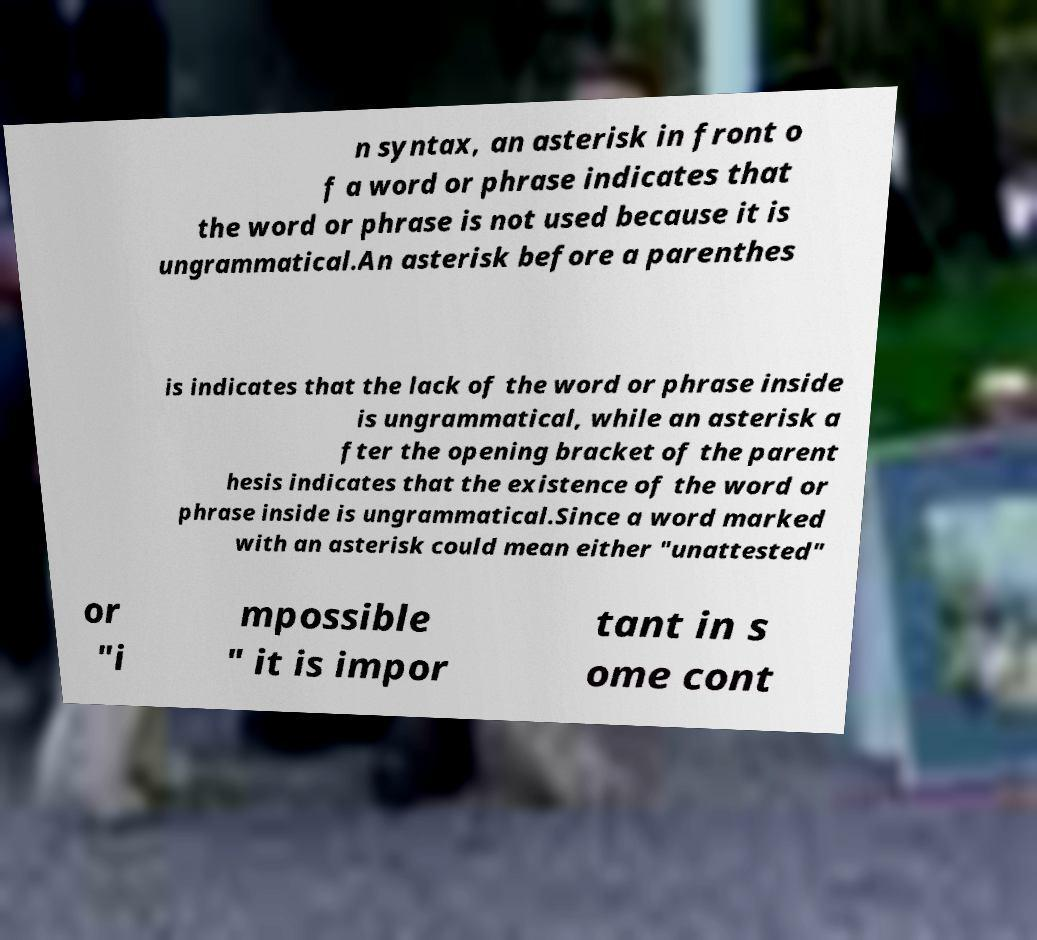There's text embedded in this image that I need extracted. Can you transcribe it verbatim? n syntax, an asterisk in front o f a word or phrase indicates that the word or phrase is not used because it is ungrammatical.An asterisk before a parenthes is indicates that the lack of the word or phrase inside is ungrammatical, while an asterisk a fter the opening bracket of the parent hesis indicates that the existence of the word or phrase inside is ungrammatical.Since a word marked with an asterisk could mean either "unattested" or "i mpossible " it is impor tant in s ome cont 